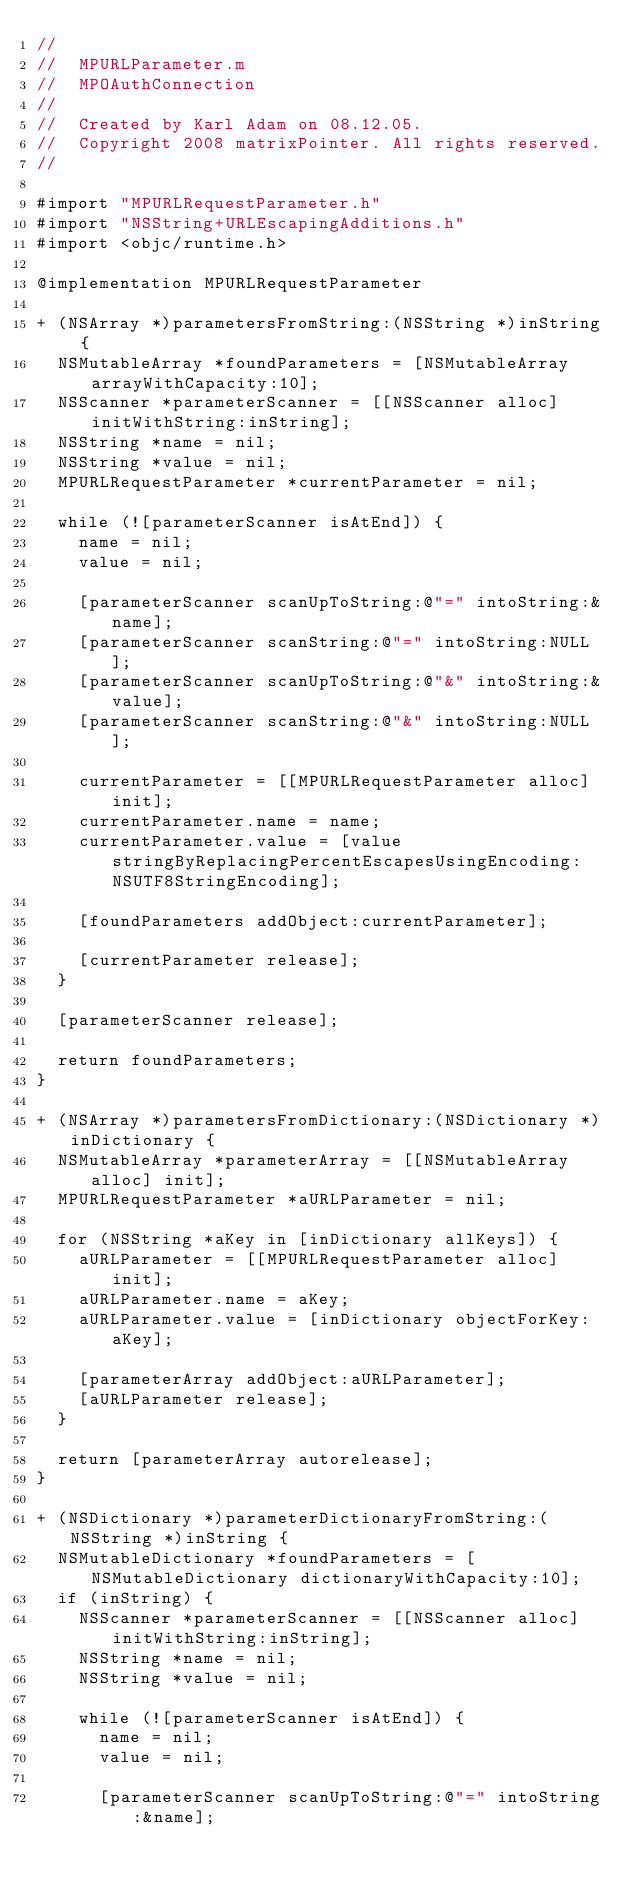<code> <loc_0><loc_0><loc_500><loc_500><_ObjectiveC_>//
//  MPURLParameter.m
//  MPOAuthConnection
//
//  Created by Karl Adam on 08.12.05.
//  Copyright 2008 matrixPointer. All rights reserved.
//

#import "MPURLRequestParameter.h"
#import "NSString+URLEscapingAdditions.h"
#import <objc/runtime.h>

@implementation MPURLRequestParameter

+ (NSArray *)parametersFromString:(NSString *)inString {
	NSMutableArray *foundParameters = [NSMutableArray arrayWithCapacity:10];
	NSScanner *parameterScanner = [[NSScanner alloc] initWithString:inString];
	NSString *name = nil;
	NSString *value = nil;
	MPURLRequestParameter *currentParameter = nil;
	
	while (![parameterScanner isAtEnd]) {
		name = nil;
		value = nil;
		
		[parameterScanner scanUpToString:@"=" intoString:&name];
		[parameterScanner scanString:@"=" intoString:NULL];
		[parameterScanner scanUpToString:@"&" intoString:&value];
		[parameterScanner scanString:@"&" intoString:NULL];		
		
		currentParameter = [[MPURLRequestParameter alloc] init];
		currentParameter.name = name;
		currentParameter.value = [value stringByReplacingPercentEscapesUsingEncoding:NSUTF8StringEncoding];
		
		[foundParameters addObject:currentParameter];
		
		[currentParameter release];
	}
	
	[parameterScanner release];
	
	return foundParameters;
}

+ (NSArray *)parametersFromDictionary:(NSDictionary *)inDictionary {
	NSMutableArray *parameterArray = [[NSMutableArray alloc] init];
	MPURLRequestParameter *aURLParameter = nil;
	
	for (NSString *aKey in [inDictionary allKeys]) {
		aURLParameter = [[MPURLRequestParameter alloc] init];
		aURLParameter.name = aKey;
		aURLParameter.value = [inDictionary objectForKey:aKey];
		
		[parameterArray addObject:aURLParameter];
		[aURLParameter release];
	}
	
	return [parameterArray autorelease];
}

+ (NSDictionary *)parameterDictionaryFromString:(NSString *)inString {
	NSMutableDictionary *foundParameters = [NSMutableDictionary dictionaryWithCapacity:10];
	if (inString) {
		NSScanner *parameterScanner = [[NSScanner alloc] initWithString:inString];
		NSString *name = nil;
		NSString *value = nil;
		
		while (![parameterScanner isAtEnd]) {
			name = nil;
			value = nil;
			
			[parameterScanner scanUpToString:@"=" intoString:&name];</code> 